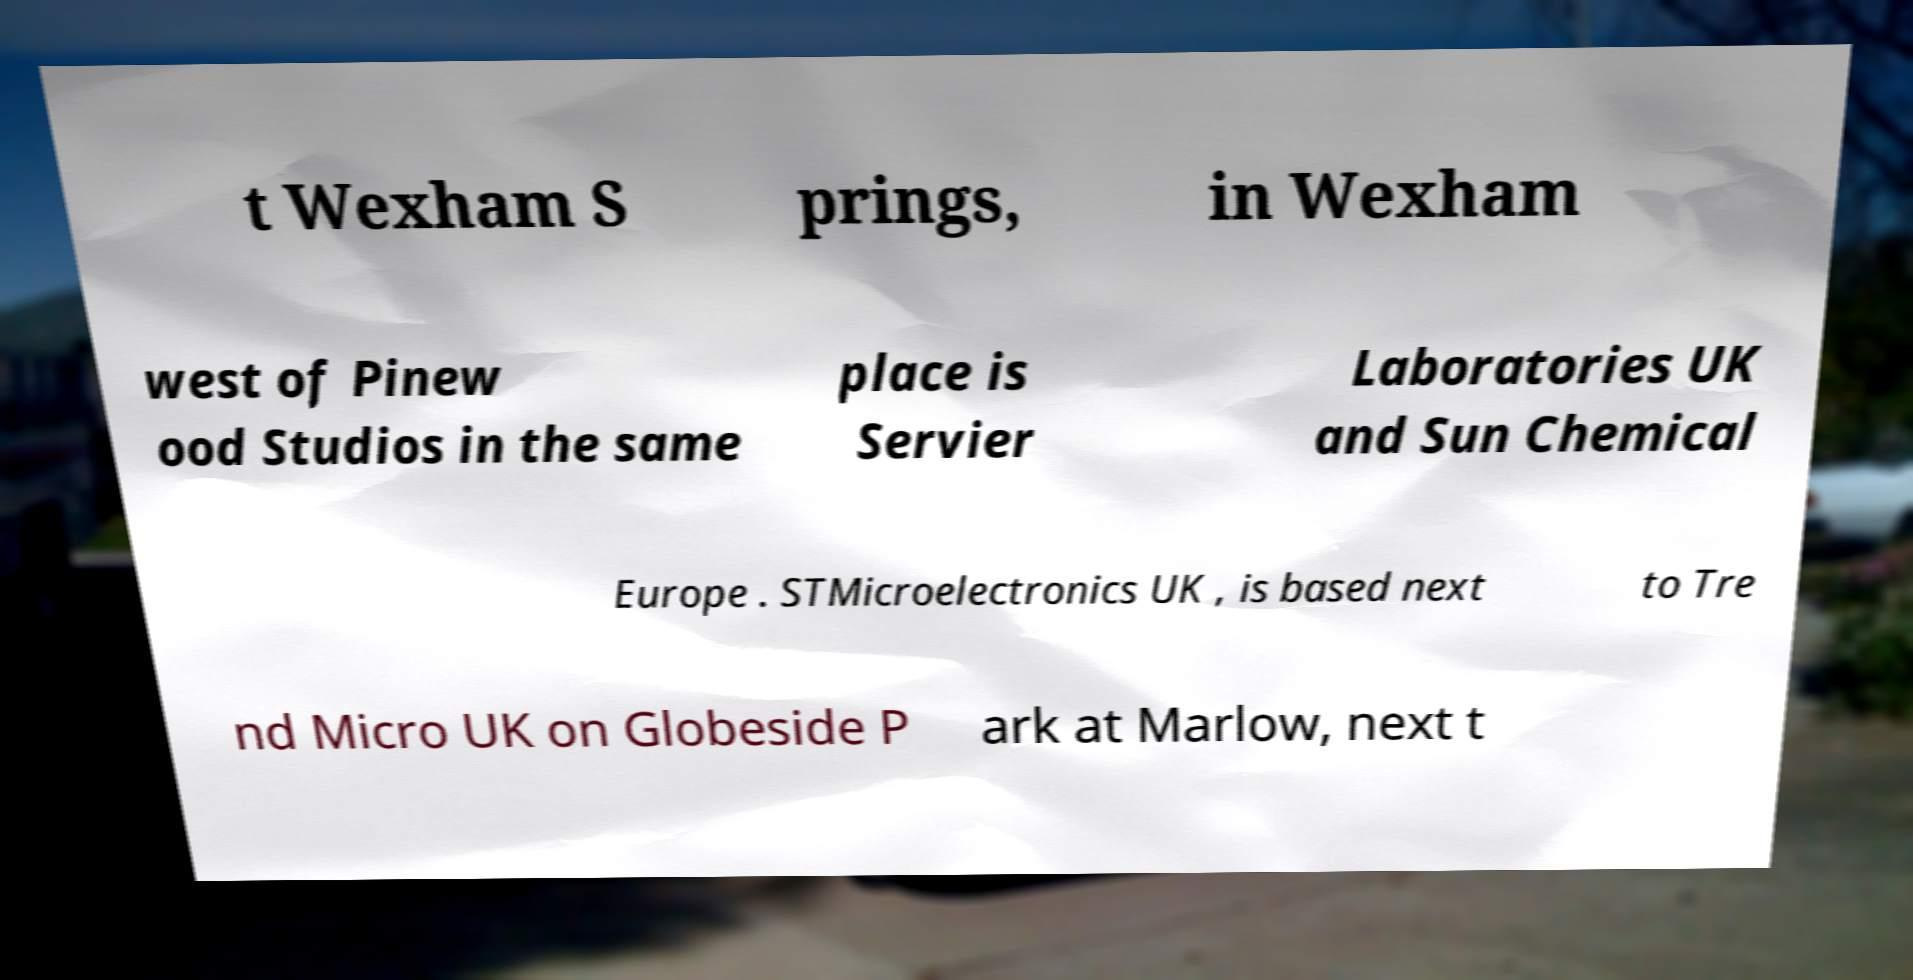There's text embedded in this image that I need extracted. Can you transcribe it verbatim? t Wexham S prings, in Wexham west of Pinew ood Studios in the same place is Servier Laboratories UK and Sun Chemical Europe . STMicroelectronics UK , is based next to Tre nd Micro UK on Globeside P ark at Marlow, next t 